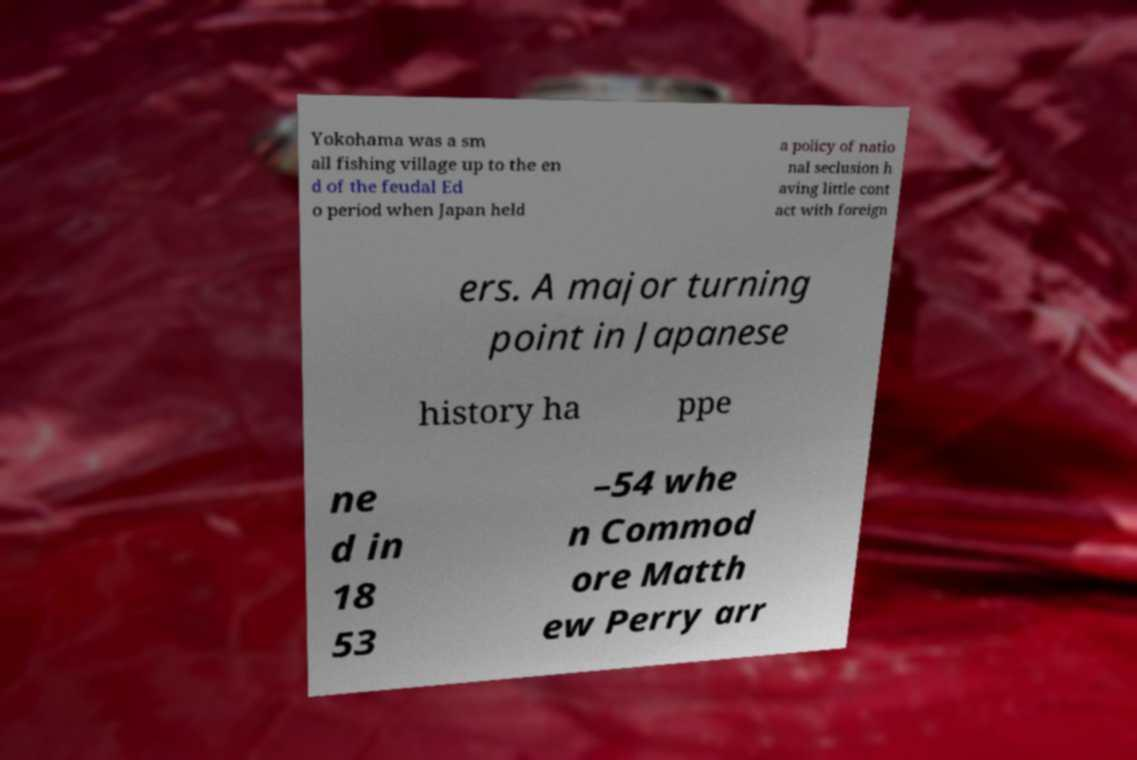Please read and relay the text visible in this image. What does it say? Yokohama was a sm all fishing village up to the en d of the feudal Ed o period when Japan held a policy of natio nal seclusion h aving little cont act with foreign ers. A major turning point in Japanese history ha ppe ne d in 18 53 –54 whe n Commod ore Matth ew Perry arr 